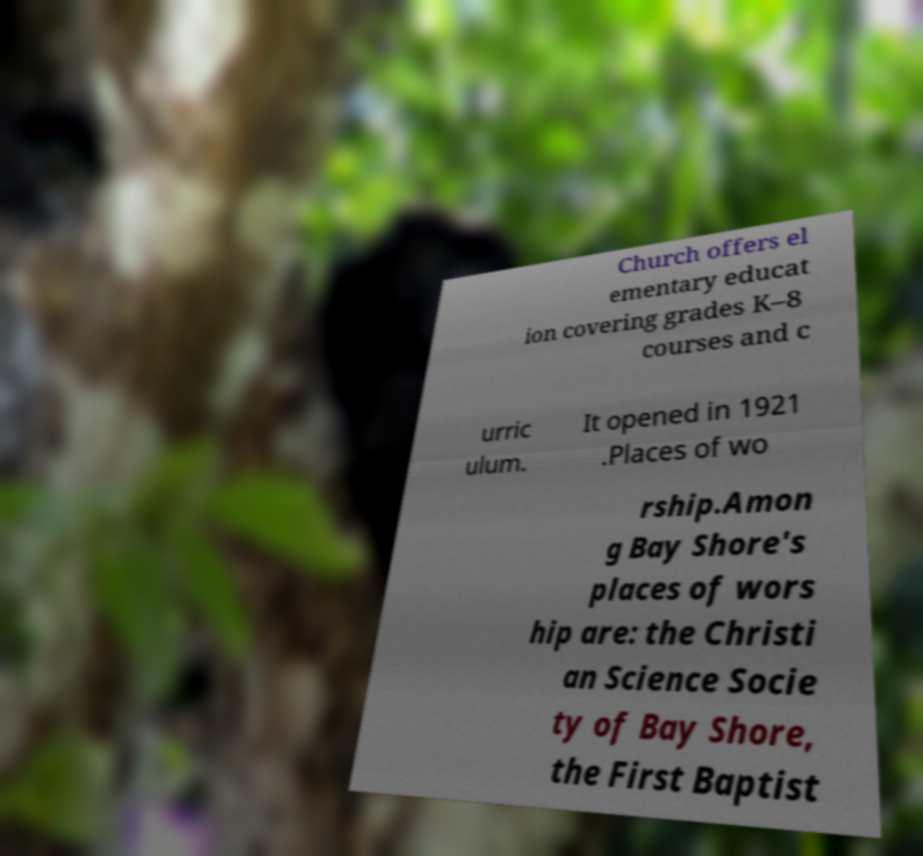Can you accurately transcribe the text from the provided image for me? Church offers el ementary educat ion covering grades K–8 courses and c urric ulum. It opened in 1921 .Places of wo rship.Amon g Bay Shore's places of wors hip are: the Christi an Science Socie ty of Bay Shore, the First Baptist 